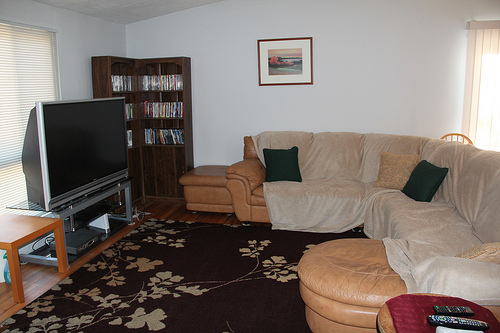What can you tell me about the large seating feature in the room? The room features a large, L-shaped beige sofa that dominates the living space. It's accompanied by a variety of pillows and extends into a chaise, providing ample space for relaxation and social gatherings. How does this furniture piece affect the ambiance of the room? The sofa's large size and warm color scheme add a welcoming and comfortable feel to the room, making it ideal for family gatherings and leisurely activities. 